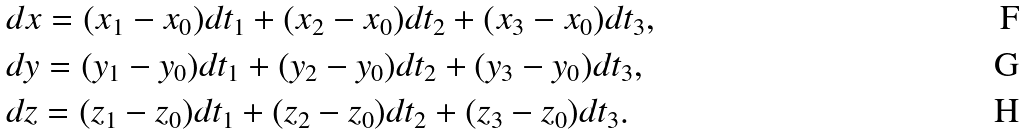<formula> <loc_0><loc_0><loc_500><loc_500>& d x = ( x _ { 1 } - x _ { 0 } ) d t _ { 1 } + ( x _ { 2 } - x _ { 0 } ) d t _ { 2 } + ( x _ { 3 } - x _ { 0 } ) d t _ { 3 } , \\ & d y = ( y _ { 1 } - y _ { 0 } ) d t _ { 1 } + ( y _ { 2 } - y _ { 0 } ) d t _ { 2 } + ( y _ { 3 } - y _ { 0 } ) d t _ { 3 } , \\ & d z = ( z _ { 1 } - z _ { 0 } ) d t _ { 1 } + ( z _ { 2 } - z _ { 0 } ) d t _ { 2 } + ( z _ { 3 } - z _ { 0 } ) d t _ { 3 } .</formula> 